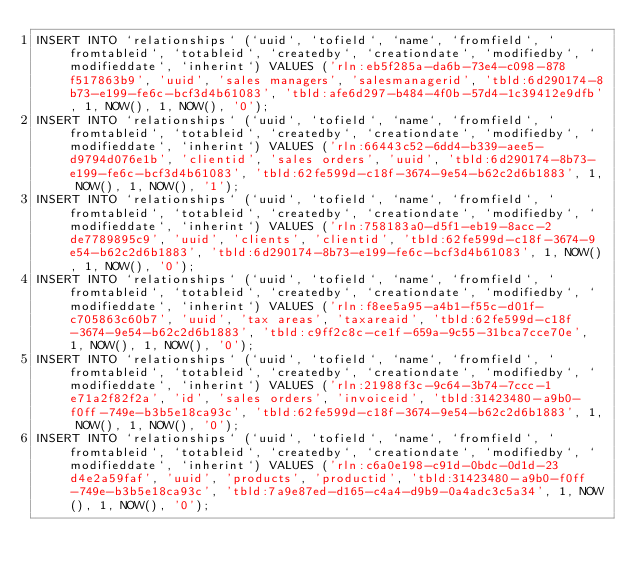<code> <loc_0><loc_0><loc_500><loc_500><_SQL_>INSERT INTO `relationships` (`uuid`, `tofield`, `name`, `fromfield`, `fromtableid`, `totableid`, `createdby`, `creationdate`, `modifiedby`, `modifieddate`, `inherint`) VALUES ('rln:eb5f285a-da6b-73e4-c098-878f517863b9', 'uuid', 'sales managers', 'salesmanagerid', 'tbld:6d290174-8b73-e199-fe6c-bcf3d4b61083', 'tbld:afe6d297-b484-4f0b-57d4-1c39412e9dfb', 1, NOW(), 1, NOW(), '0');
INSERT INTO `relationships` (`uuid`, `tofield`, `name`, `fromfield`, `fromtableid`, `totableid`, `createdby`, `creationdate`, `modifiedby`, `modifieddate`, `inherint`) VALUES ('rln:66443c52-6dd4-b339-aee5-d9794d076e1b', 'clientid', 'sales orders', 'uuid', 'tbld:6d290174-8b73-e199-fe6c-bcf3d4b61083', 'tbld:62fe599d-c18f-3674-9e54-b62c2d6b1883', 1, NOW(), 1, NOW(), '1');
INSERT INTO `relationships` (`uuid`, `tofield`, `name`, `fromfield`, `fromtableid`, `totableid`, `createdby`, `creationdate`, `modifiedby`, `modifieddate`, `inherint`) VALUES ('rln:758183a0-d5f1-eb19-8acc-2de7789895c9', 'uuid', 'clients', 'clientid', 'tbld:62fe599d-c18f-3674-9e54-b62c2d6b1883', 'tbld:6d290174-8b73-e199-fe6c-bcf3d4b61083', 1, NOW(), 1, NOW(), '0');
INSERT INTO `relationships` (`uuid`, `tofield`, `name`, `fromfield`, `fromtableid`, `totableid`, `createdby`, `creationdate`, `modifiedby`, `modifieddate`, `inherint`) VALUES ('rln:f8ee5a95-a4b1-f55c-d01f-c705863c60b7', 'uuid', 'tax areas', 'taxareaid', 'tbld:62fe599d-c18f-3674-9e54-b62c2d6b1883', 'tbld:c9ff2c8c-ce1f-659a-9c55-31bca7cce70e', 1, NOW(), 1, NOW(), '0');
INSERT INTO `relationships` (`uuid`, `tofield`, `name`, `fromfield`, `fromtableid`, `totableid`, `createdby`, `creationdate`, `modifiedby`, `modifieddate`, `inherint`) VALUES ('rln:21988f3c-9c64-3b74-7ccc-1e71a2f82f2a', 'id', 'sales orders', 'invoiceid', 'tbld:31423480-a9b0-f0ff-749e-b3b5e18ca93c', 'tbld:62fe599d-c18f-3674-9e54-b62c2d6b1883', 1, NOW(), 1, NOW(), '0');
INSERT INTO `relationships` (`uuid`, `tofield`, `name`, `fromfield`, `fromtableid`, `totableid`, `createdby`, `creationdate`, `modifiedby`, `modifieddate`, `inherint`) VALUES ('rln:c6a0e198-c91d-0bdc-0d1d-23d4e2a59faf', 'uuid', 'products', 'productid', 'tbld:31423480-a9b0-f0ff-749e-b3b5e18ca93c', 'tbld:7a9e87ed-d165-c4a4-d9b9-0a4adc3c5a34', 1, NOW(), 1, NOW(), '0');</code> 